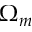<formula> <loc_0><loc_0><loc_500><loc_500>\Omega _ { m }</formula> 